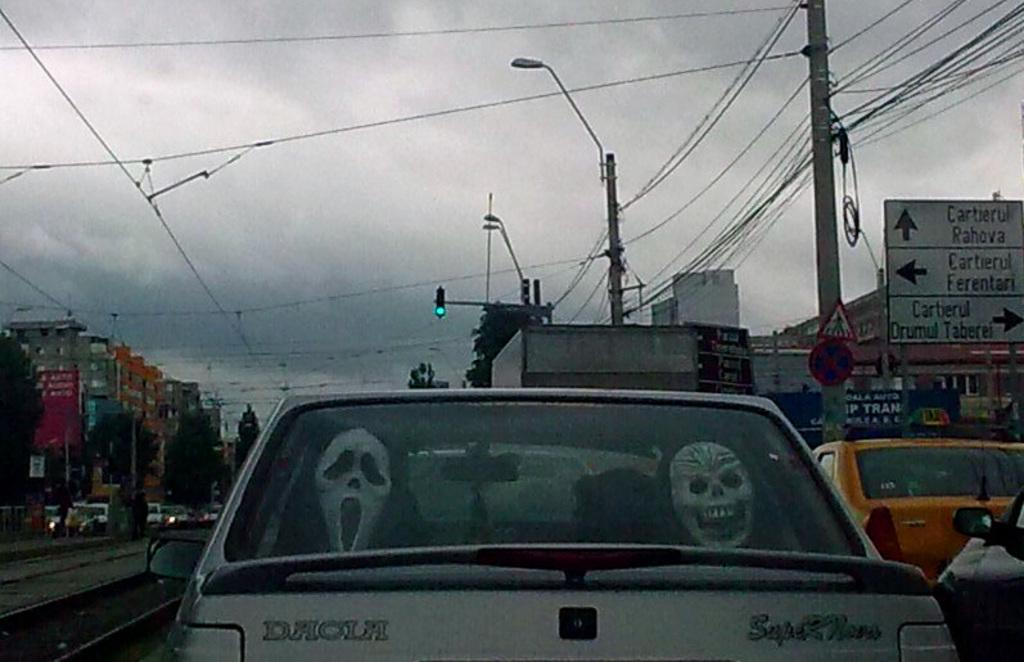<image>
Describe the image concisely. Two scary Halloween masks in the back window of a white Daola Car. 